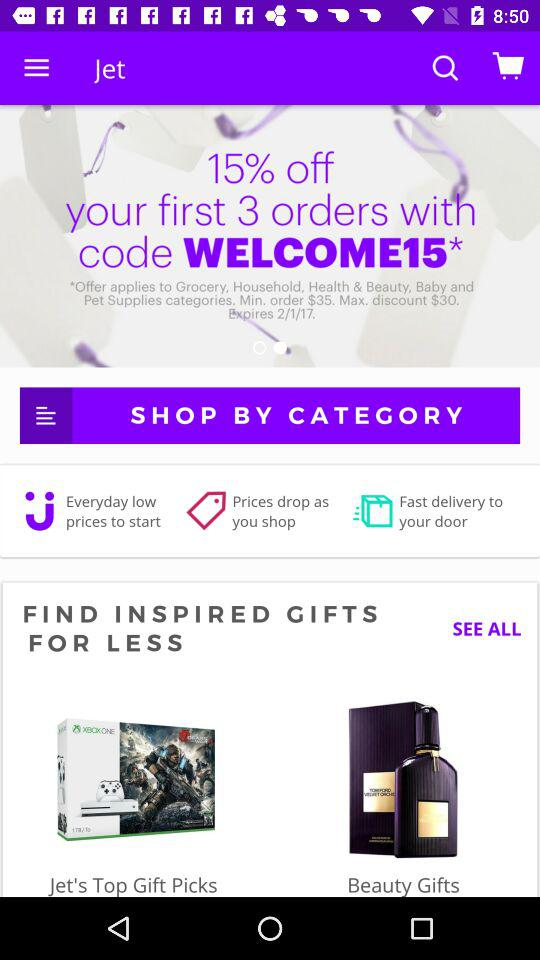What is the minimum order value? The minimum order value is $35. 